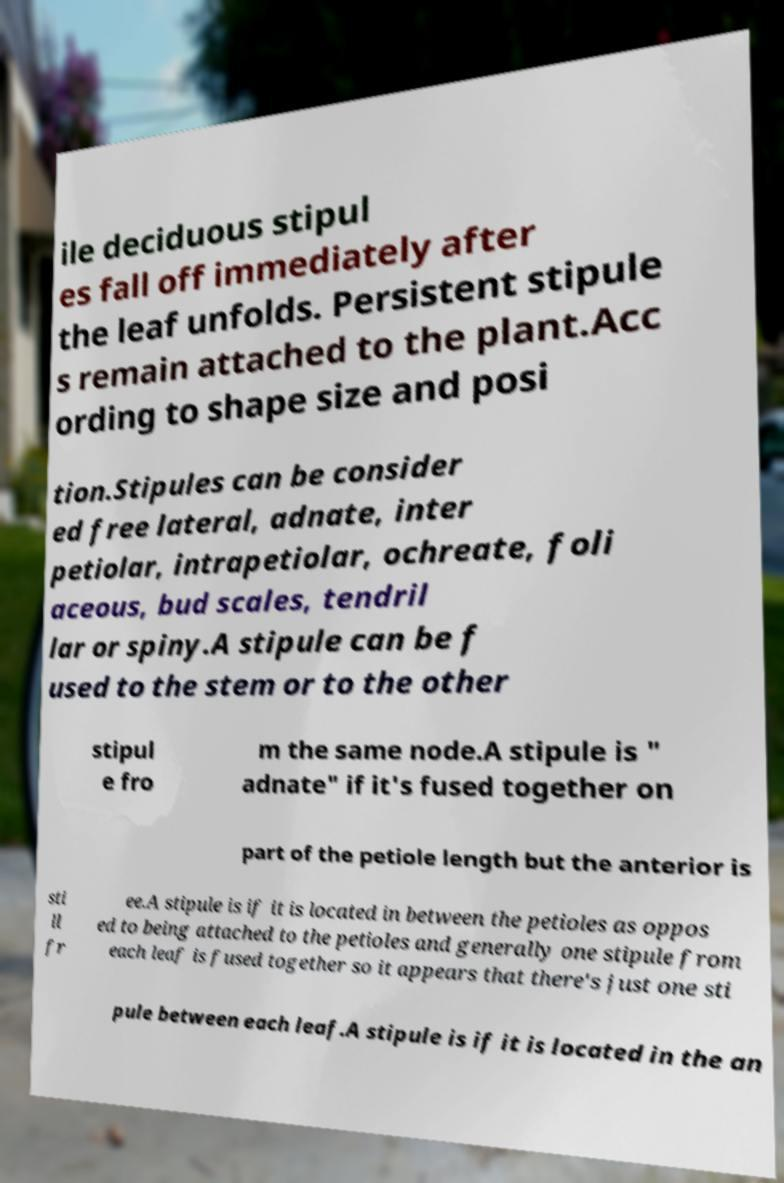There's text embedded in this image that I need extracted. Can you transcribe it verbatim? ile deciduous stipul es fall off immediately after the leaf unfolds. Persistent stipule s remain attached to the plant.Acc ording to shape size and posi tion.Stipules can be consider ed free lateral, adnate, inter petiolar, intrapetiolar, ochreate, foli aceous, bud scales, tendril lar or spiny.A stipule can be f used to the stem or to the other stipul e fro m the same node.A stipule is " adnate" if it's fused together on part of the petiole length but the anterior is sti ll fr ee.A stipule is if it is located in between the petioles as oppos ed to being attached to the petioles and generally one stipule from each leaf is fused together so it appears that there's just one sti pule between each leaf.A stipule is if it is located in the an 